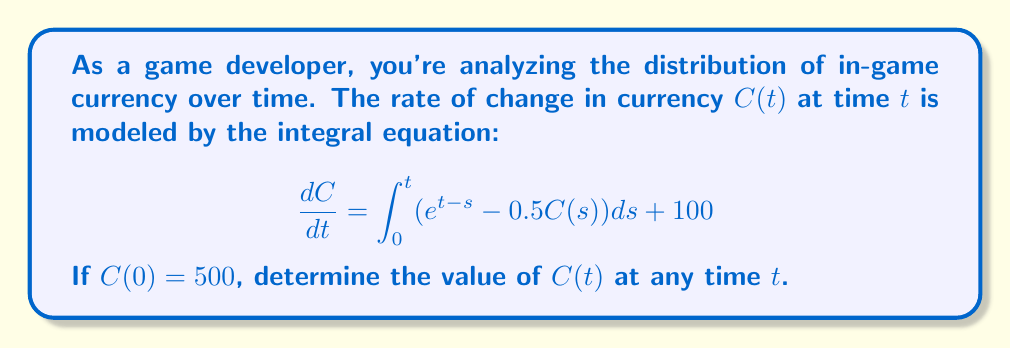Provide a solution to this math problem. Let's solve this step-by-step:

1) First, we need to differentiate both sides of the equation with respect to $t$:

   $$\frac{d^2C}{dt^2} = \frac{d}{dt}\left[\int_0^t (e^{t-s} - 0.5C(s)) ds + 100\right]$$

2) Using the fundamental theorem of calculus:

   $$\frac{d^2C}{dt^2} = e^{t-t} - 0.5C(t) + \int_0^t e^{t-s} \frac{d}{dt}ds$$

3) Simplify:

   $$\frac{d^2C}{dt^2} = 1 - 0.5C(t) + \int_0^t e^{t-s} ds$$

4) Evaluate the integral:

   $$\frac{d^2C}{dt^2} = 1 - 0.5C(t) + e^t \int_0^t e^{-s} ds = 1 - 0.5C(t) + e^t [1 - e^{-t}] = e^t$$

5) We now have a second-order linear differential equation:

   $$\frac{d^2C}{dt^2} + 0.5C(t) = e^t + 1$$

6) The general solution to this equation is:

   $$C(t) = A\cos(\frac{\sqrt{2}}{2}t) + B\sin(\frac{\sqrt{2}}{2}t) + 2e^t - 2$$

7) Using the initial condition $C(0) = 500$:

   $$500 = A + 2 - 2$$
   $$A = 500$$

8) To find B, we use the initial rate of change from the original equation:

   $$\frac{dC}{dt}(0) = \int_0^0 (e^{0-s} - 0.5C(s)) ds + 100 = 100$$

   $$100 = -\frac{\sqrt{2}}{2}A\sin(0) + \frac{\sqrt{2}}{2}B\cos(0) + 2$$
   $$B = \frac{98\sqrt{2}}{2}$$

9) Therefore, the final solution is:

   $$C(t) = 500\cos(\frac{\sqrt{2}}{2}t) + 98\sqrt{2}\sin(\frac{\sqrt{2}}{2}t) + 2e^t - 2$$
Answer: $C(t) = 500\cos(\frac{\sqrt{2}}{2}t) + 98\sqrt{2}\sin(\frac{\sqrt{2}}{2}t) + 2e^t - 2$ 